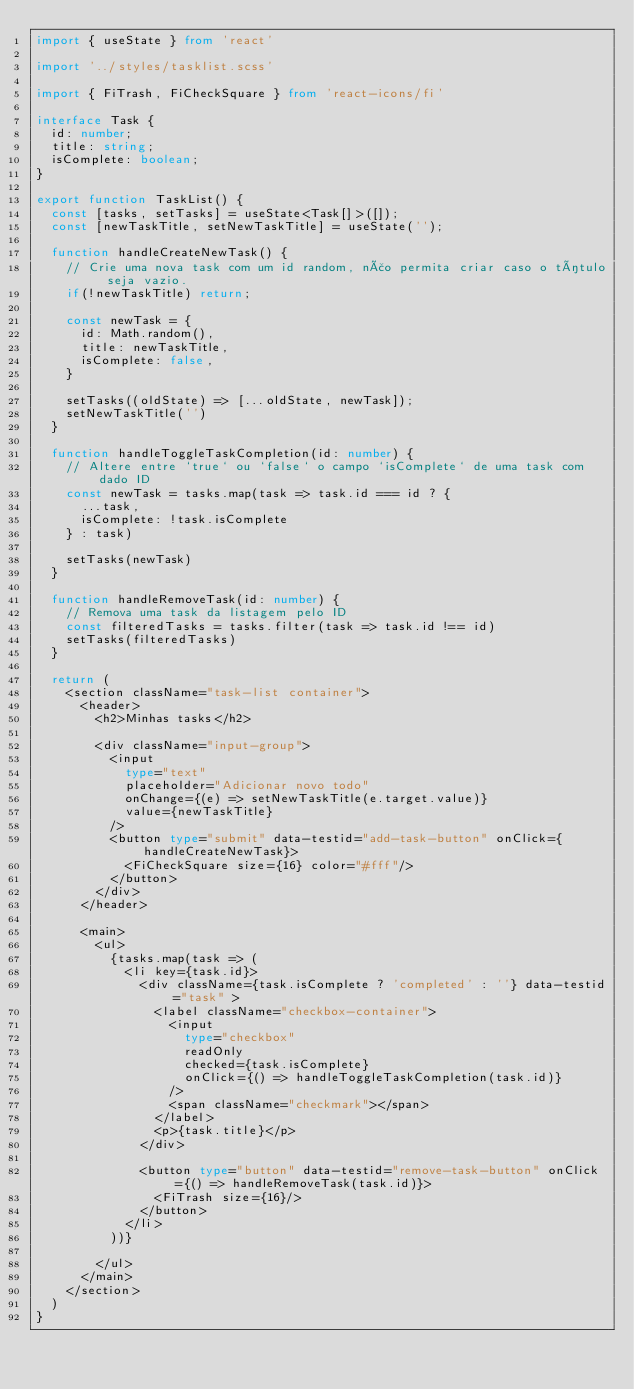Convert code to text. <code><loc_0><loc_0><loc_500><loc_500><_TypeScript_>import { useState } from 'react'

import '../styles/tasklist.scss'

import { FiTrash, FiCheckSquare } from 'react-icons/fi'

interface Task {
  id: number;
  title: string;
  isComplete: boolean;
}

export function TaskList() {
  const [tasks, setTasks] = useState<Task[]>([]);
  const [newTaskTitle, setNewTaskTitle] = useState('');

  function handleCreateNewTask() {
    // Crie uma nova task com um id random, não permita criar caso o título seja vazio.
    if(!newTaskTitle) return;
    
    const newTask = {
      id: Math.random(),
      title: newTaskTitle,
      isComplete: false,
    }

    setTasks((oldState) => [...oldState, newTask]);
    setNewTaskTitle('')
  }

  function handleToggleTaskCompletion(id: number) {
    // Altere entre `true` ou `false` o campo `isComplete` de uma task com dado ID
    const newTask = tasks.map(task => task.id === id ? {
      ...task,
      isComplete: !task.isComplete
    } : task)

    setTasks(newTask)
  }

  function handleRemoveTask(id: number) {
    // Remova uma task da listagem pelo ID
    const filteredTasks = tasks.filter(task => task.id !== id)
    setTasks(filteredTasks)
  }

  return (
    <section className="task-list container">
      <header>
        <h2>Minhas tasks</h2>

        <div className="input-group">
          <input 
            type="text" 
            placeholder="Adicionar novo todo" 
            onChange={(e) => setNewTaskTitle(e.target.value)}
            value={newTaskTitle}
          />
          <button type="submit" data-testid="add-task-button" onClick={handleCreateNewTask}>
            <FiCheckSquare size={16} color="#fff"/>
          </button>
        </div>
      </header>

      <main>
        <ul>
          {tasks.map(task => (
            <li key={task.id}>
              <div className={task.isComplete ? 'completed' : ''} data-testid="task" >
                <label className="checkbox-container">
                  <input 
                    type="checkbox"
                    readOnly
                    checked={task.isComplete}
                    onClick={() => handleToggleTaskCompletion(task.id)}
                  />
                  <span className="checkmark"></span>
                </label>
                <p>{task.title}</p>
              </div>

              <button type="button" data-testid="remove-task-button" onClick={() => handleRemoveTask(task.id)}>
                <FiTrash size={16}/>
              </button>
            </li>
          ))}
          
        </ul>
      </main>
    </section>
  )
}</code> 